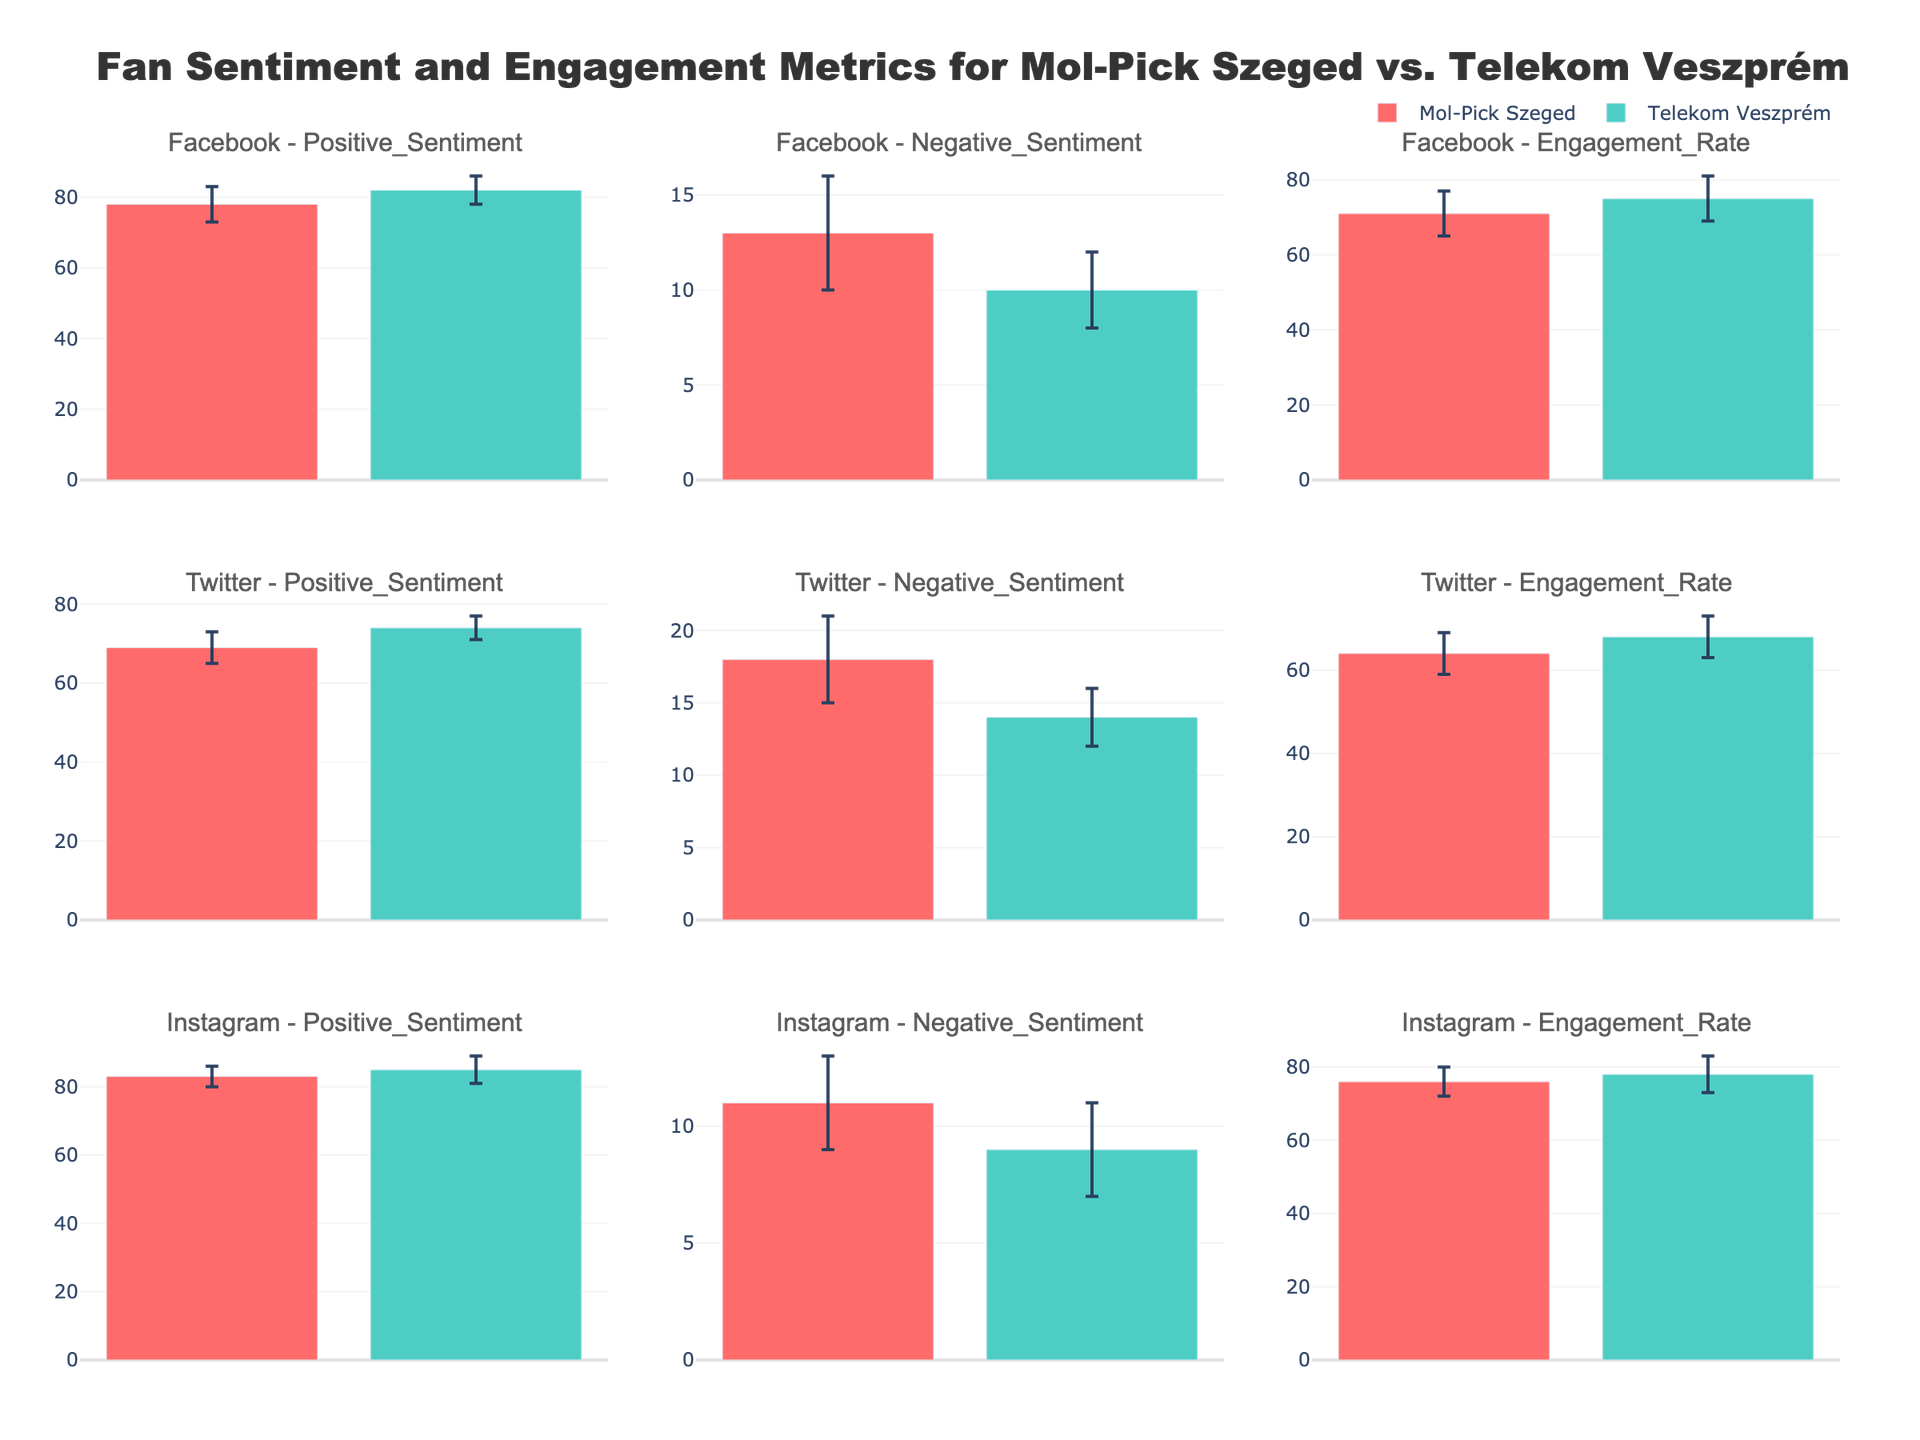How does the engagement rate of Mol-Pick Szeged on Facebook compare to that on Twitter? To find the engagement rates of Mol-Pick Szeged on Facebook and Twitter, look at the respective subplots. On Facebook, the engagement rate for Mol-Pick Szeged is 71. On Twitter, it is 64. This shows that the engagement rate on Facebook is higher than on Twitter.
Answer: The engagement rate on Facebook is higher compared to Twitter Which team has a higher positive sentiment on Instagram? To determine this, look at the Positive Sentiment subplot for Instagram. Mol-Pick Szeged has a mean positive sentiment of 83, while Telekom Veszprém has a mean positive sentiment of 85. Therefore, Telekom Veszprém has a higher positive sentiment on Instagram.
Answer: Telekom Veszprém What is the difference in negative sentiment between Mol-Pick Szeged and Telekom Veszprém on Facebook? On the Facebook - Negative Sentiment subplot, Mol-Pick Szeged has a mean negative sentiment of 13, while Telekom Veszprém has a mean of 10. The difference is 13 - 10 = 3.
Answer: 3 Compare the error bars for the engagement rate on Instagram between the two teams. In the Instagram - Engagement Rate subplot, Mol-Pick Szeged has an error bar of 4, while Telekom Veszprém has an error bar of 5. This shows that Telekom Veszprém has a slightly larger error bar for engagement rate on Instagram.
Answer: Telekom Veszprém's error bar is larger Which platform shows the highest positive sentiment for Mol-Pick Szeged? To find this, you need to compare the positive sentiment values for Mol-Pick Szeged across all platforms (Facebook, Twitter, Instagram). The respective values are 78 (Facebook), 69 (Twitter), and 83 (Instagram). The highest is on Instagram at 83.
Answer: Instagram Is the engagement rate on Facebook for Telekom Veszprém within the error margin of Mol-Pick Szeged's engagement rate on Facebook? On Facebook, Telekom Veszprém's engagement rate is 75, and Mol-Pick Szeged's engagement rate is 71 with an error margin of 6. This means the range for Mol-Pick Szeged is from 65 to 77. Since 75 is within this range, Telekom Veszprém's engagement rate falls within Mol-Pick Szeged's error margin.
Answer: Yes Which team has a more positive sentiment on Twitter? According to the Twitter - Positive Sentiment subplot, Mol-Pick Szeged has a mean positive sentiment of 69, whereas Telekom Veszprém's mean is 74. Hence, Telekom Veszprém has a more positive sentiment on Twitter.
Answer: Telekom Veszprém What is the error margin of the positive sentiment for Mol-Pick Szeged on Instagram? On the Instagram - Positive Sentiment subplot, the error margin for Mol-Pick Szeged's positive sentiment is given as 3.
Answer: 3 Compare the negative sentiment for Mol-Pick Szeged on Facebook and Instagram. Looking at the subplots for Negative Sentiment on both platforms, Mol-Pick Szeged has a mean value of 13 on Facebook and 11 on Instagram. So the negative sentiment is lower on Instagram compared to Facebook.
Answer: Lower on Instagram Explain the engagement rates on Twitter for both teams. For Twitter - Engagement Rate, Mol-Pick Szeged has a mean engagement rate of 64, while Telekom Veszprém has 68. Analyzing this, Telekom Veszprém has a slightly higher engagement rate on Twitter than Mol-Pick Szeged by 4.
Answer: Telekom Veszprém 